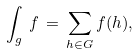<formula> <loc_0><loc_0><loc_500><loc_500>\int _ { g } \, f \, = \, \sum _ { h \in G } f ( h ) ,</formula> 